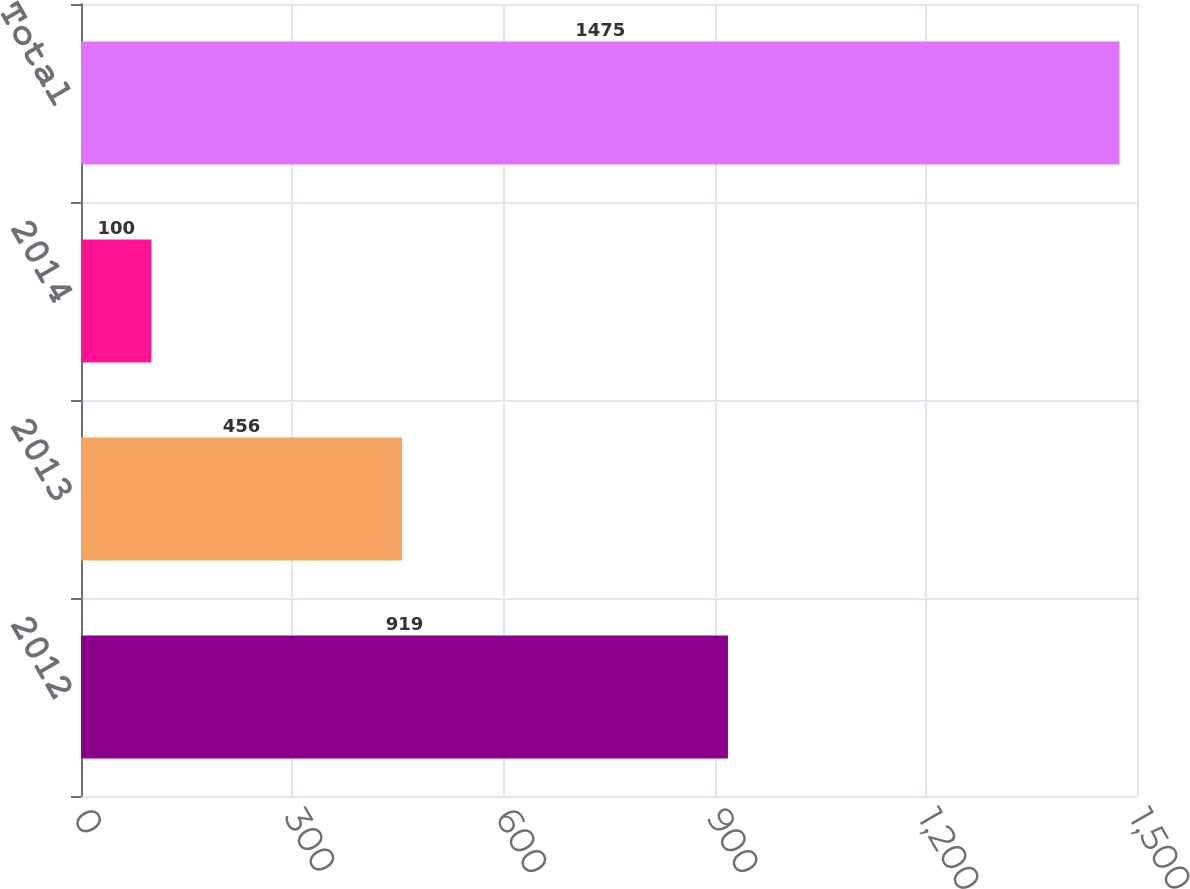Convert chart. <chart><loc_0><loc_0><loc_500><loc_500><bar_chart><fcel>2012<fcel>2013<fcel>2014<fcel>Total<nl><fcel>919<fcel>456<fcel>100<fcel>1475<nl></chart> 